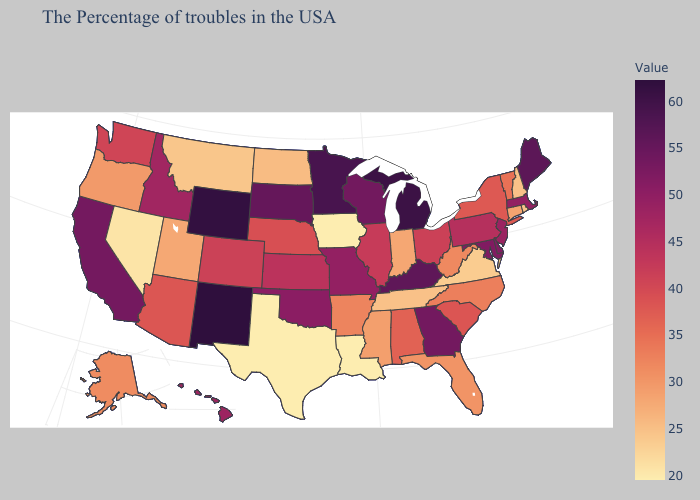Does New Jersey have the highest value in the USA?
Quick response, please. No. Does the map have missing data?
Concise answer only. No. Among the states that border Maryland , does Pennsylvania have the lowest value?
Short answer required. No. Among the states that border Maryland , does Virginia have the lowest value?
Be succinct. Yes. Does South Dakota have a lower value than Pennsylvania?
Give a very brief answer. No. 